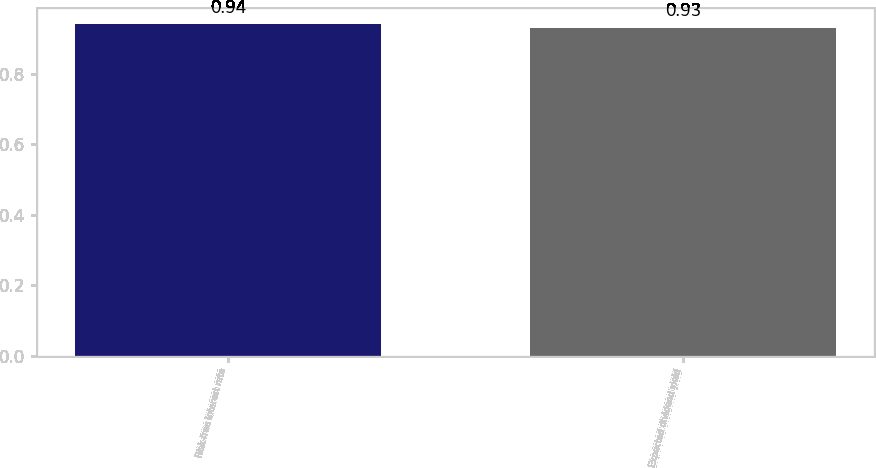<chart> <loc_0><loc_0><loc_500><loc_500><bar_chart><fcel>Risk-free interest rate<fcel>Expected dividend yield<nl><fcel>0.94<fcel>0.93<nl></chart> 